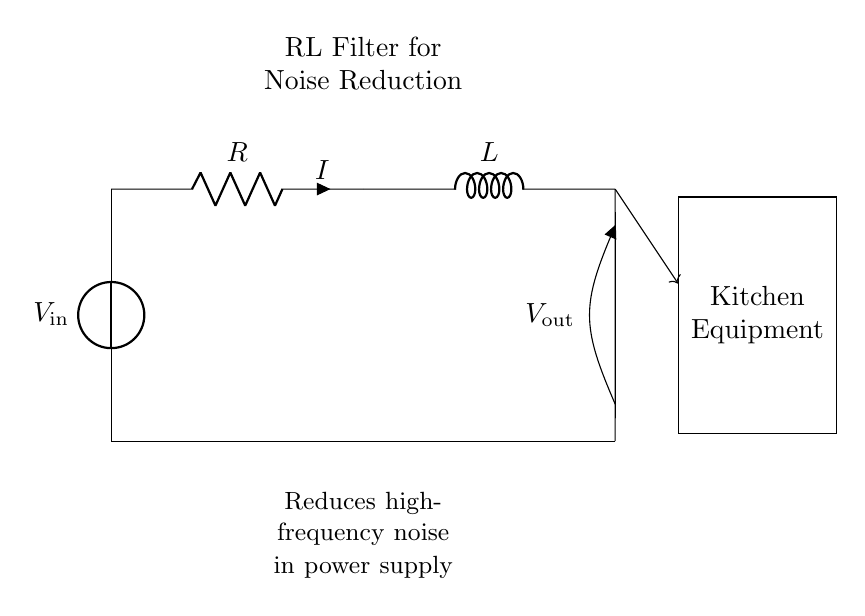What is the input voltage of this circuit? The input voltage is represented as V_in at the voltage source on the left side of the circuit diagram.
Answer: V_in What components are in the circuit? The circuit contains a resistor (R) and an inductor (L) connected in series, along with a voltage source (V_in) and a load for output.
Answer: Resistor, Inductor What is the type of the circuit? This circuit is an RL filter circuit, as indicated by the presence of a resistor and an inductor used together for filtering applications.
Answer: RL filter What is the direction of current in this circuit? The direction of current (I) is indicated by the arrow next to the resistor flowing from the voltage source through the resistor and inductor, and finally to ground.
Answer: From left to right How does this filter affect high-frequency noise? The RL filter is used to reduce high-frequency noise in power supplies by using the inductor to oppose changes in current flow, thus providing low pass filtering.
Answer: Reduces high-frequency noise What is the purpose of the inductor in this circuit? The inductor serves to store energy in a magnetic field and to resist rapid changes in current, which aids in filtering out high-frequency electrical noise.
Answer: To filter noise What is the output voltage related to? The output voltage (V_out) is across the inductor and is influenced by the input voltage and the impedance created by the resistor and inductor configuration.
Answer: V_out 